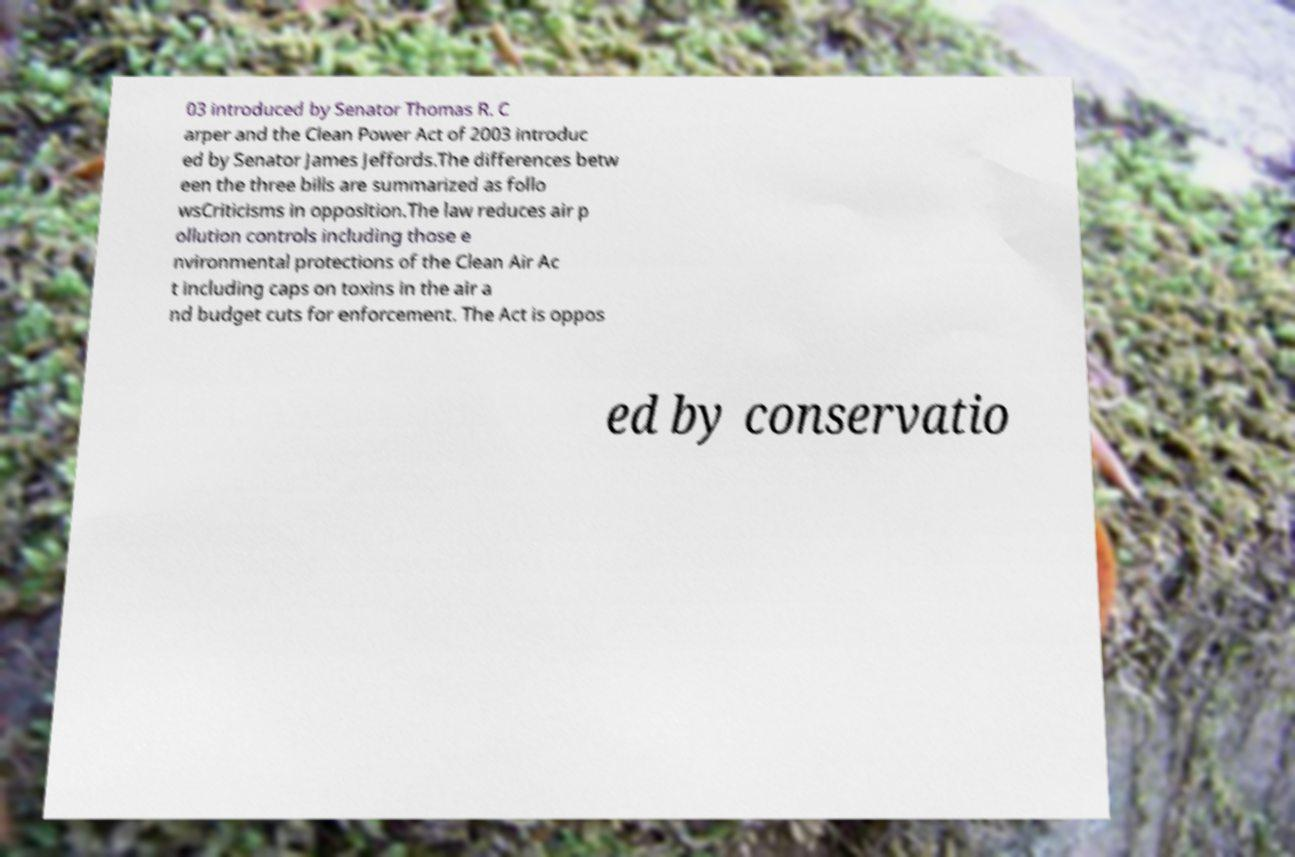Can you read and provide the text displayed in the image?This photo seems to have some interesting text. Can you extract and type it out for me? 03 introduced by Senator Thomas R. C arper and the Clean Power Act of 2003 introduc ed by Senator James Jeffords.The differences betw een the three bills are summarized as follo wsCriticisms in opposition.The law reduces air p ollution controls including those e nvironmental protections of the Clean Air Ac t including caps on toxins in the air a nd budget cuts for enforcement. The Act is oppos ed by conservatio 